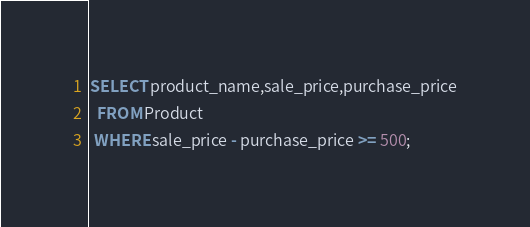Convert code to text. <code><loc_0><loc_0><loc_500><loc_500><_SQL_>SELECT product_name,sale_price,purchase_price
  FROM Product
 WHERE sale_price - purchase_price >= 500;
</code> 